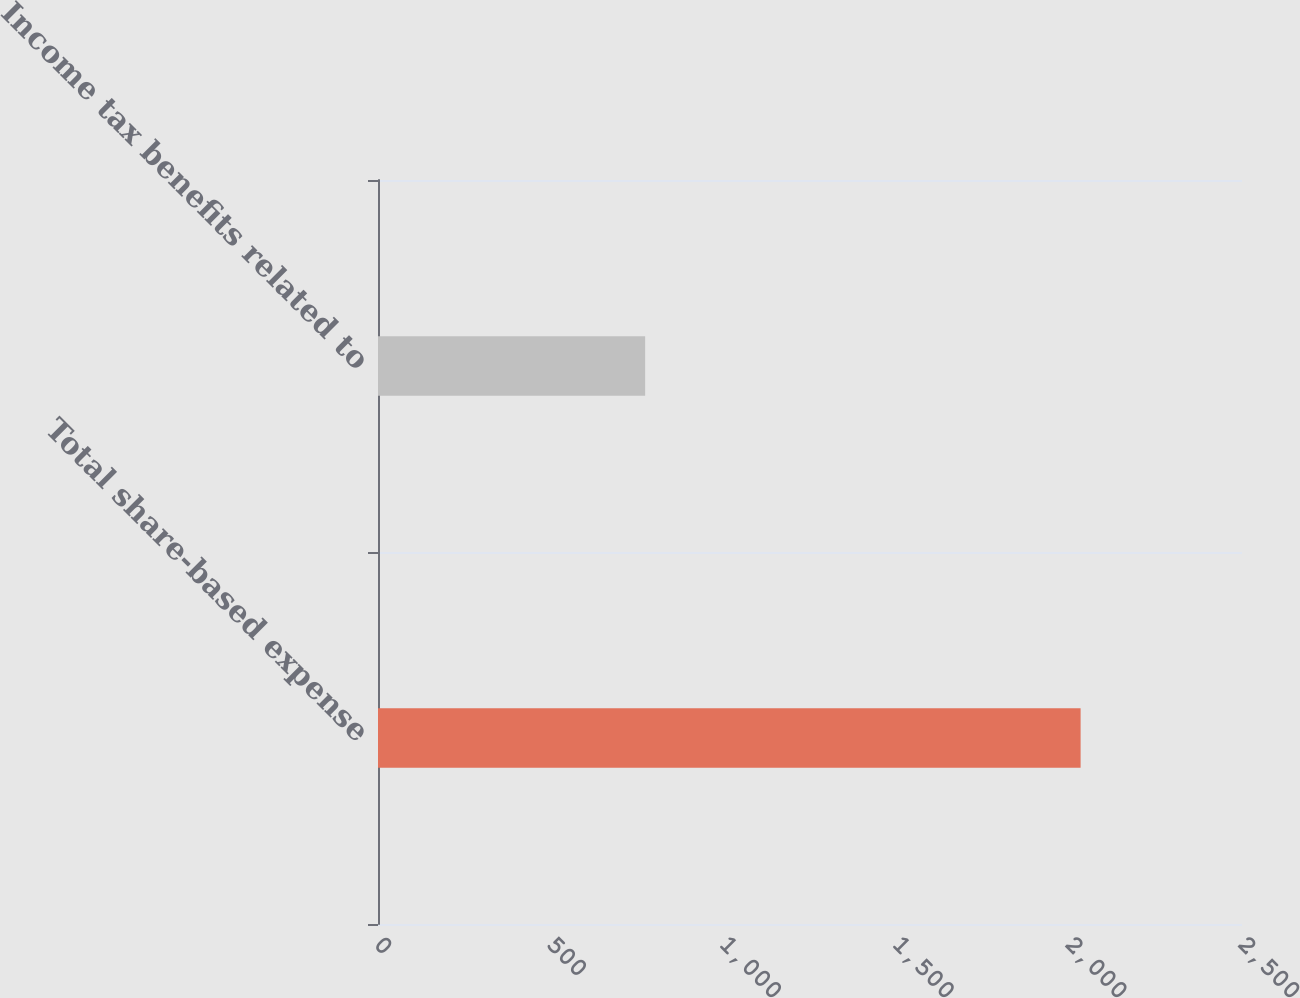<chart> <loc_0><loc_0><loc_500><loc_500><bar_chart><fcel>Total share-based expense<fcel>Income tax benefits related to<nl><fcel>2033<fcel>773<nl></chart> 